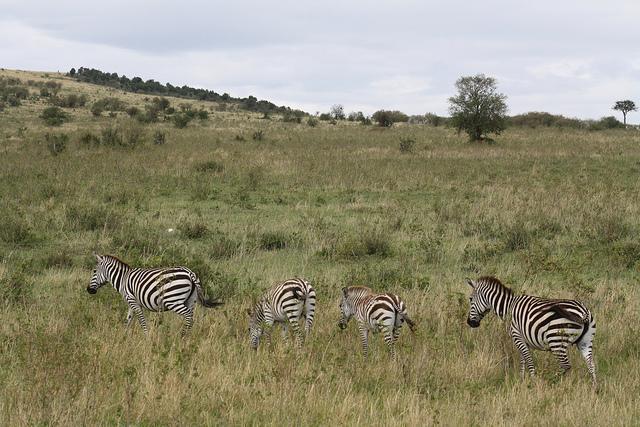How many zebras are in the photo?
Give a very brief answer. 4. How many zebras are in the picture?
Give a very brief answer. 4. How many people are facing the camera?
Give a very brief answer. 0. 